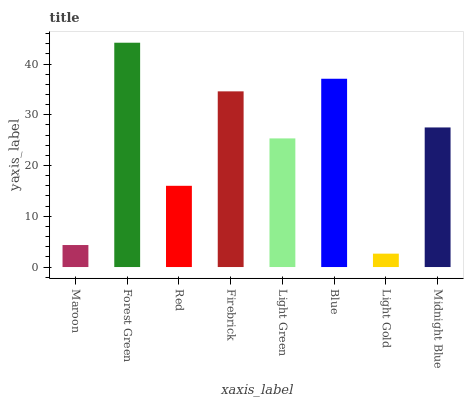Is Light Gold the minimum?
Answer yes or no. Yes. Is Forest Green the maximum?
Answer yes or no. Yes. Is Red the minimum?
Answer yes or no. No. Is Red the maximum?
Answer yes or no. No. Is Forest Green greater than Red?
Answer yes or no. Yes. Is Red less than Forest Green?
Answer yes or no. Yes. Is Red greater than Forest Green?
Answer yes or no. No. Is Forest Green less than Red?
Answer yes or no. No. Is Midnight Blue the high median?
Answer yes or no. Yes. Is Light Green the low median?
Answer yes or no. Yes. Is Firebrick the high median?
Answer yes or no. No. Is Maroon the low median?
Answer yes or no. No. 